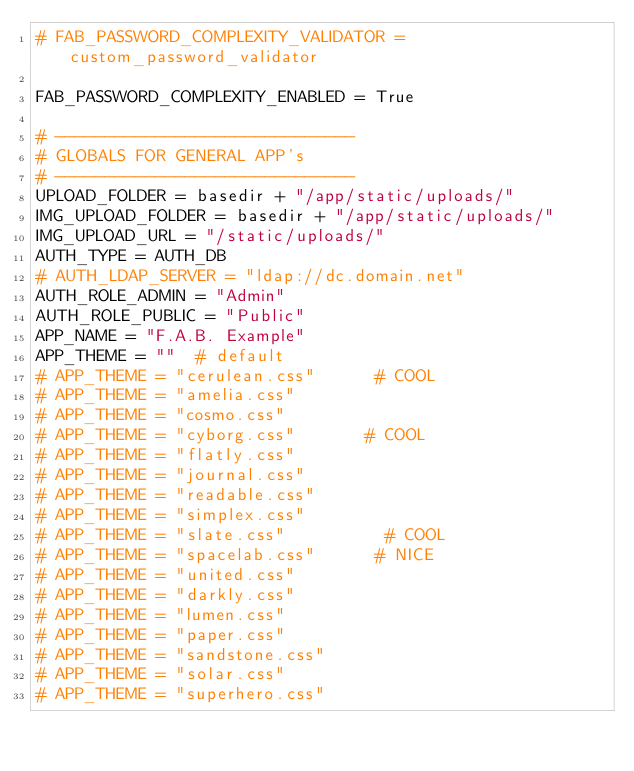Convert code to text. <code><loc_0><loc_0><loc_500><loc_500><_Python_># FAB_PASSWORD_COMPLEXITY_VALIDATOR = custom_password_validator

FAB_PASSWORD_COMPLEXITY_ENABLED = True

# ------------------------------
# GLOBALS FOR GENERAL APP's
# ------------------------------
UPLOAD_FOLDER = basedir + "/app/static/uploads/"
IMG_UPLOAD_FOLDER = basedir + "/app/static/uploads/"
IMG_UPLOAD_URL = "/static/uploads/"
AUTH_TYPE = AUTH_DB
# AUTH_LDAP_SERVER = "ldap://dc.domain.net"
AUTH_ROLE_ADMIN = "Admin"
AUTH_ROLE_PUBLIC = "Public"
APP_NAME = "F.A.B. Example"
APP_THEME = ""  # default
# APP_THEME = "cerulean.css"      # COOL
# APP_THEME = "amelia.css"
# APP_THEME = "cosmo.css"
# APP_THEME = "cyborg.css"       # COOL
# APP_THEME = "flatly.css"
# APP_THEME = "journal.css"
# APP_THEME = "readable.css"
# APP_THEME = "simplex.css"
# APP_THEME = "slate.css"          # COOL
# APP_THEME = "spacelab.css"      # NICE
# APP_THEME = "united.css"
# APP_THEME = "darkly.css"
# APP_THEME = "lumen.css"
# APP_THEME = "paper.css"
# APP_THEME = "sandstone.css"
# APP_THEME = "solar.css"
# APP_THEME = "superhero.css"

</code> 